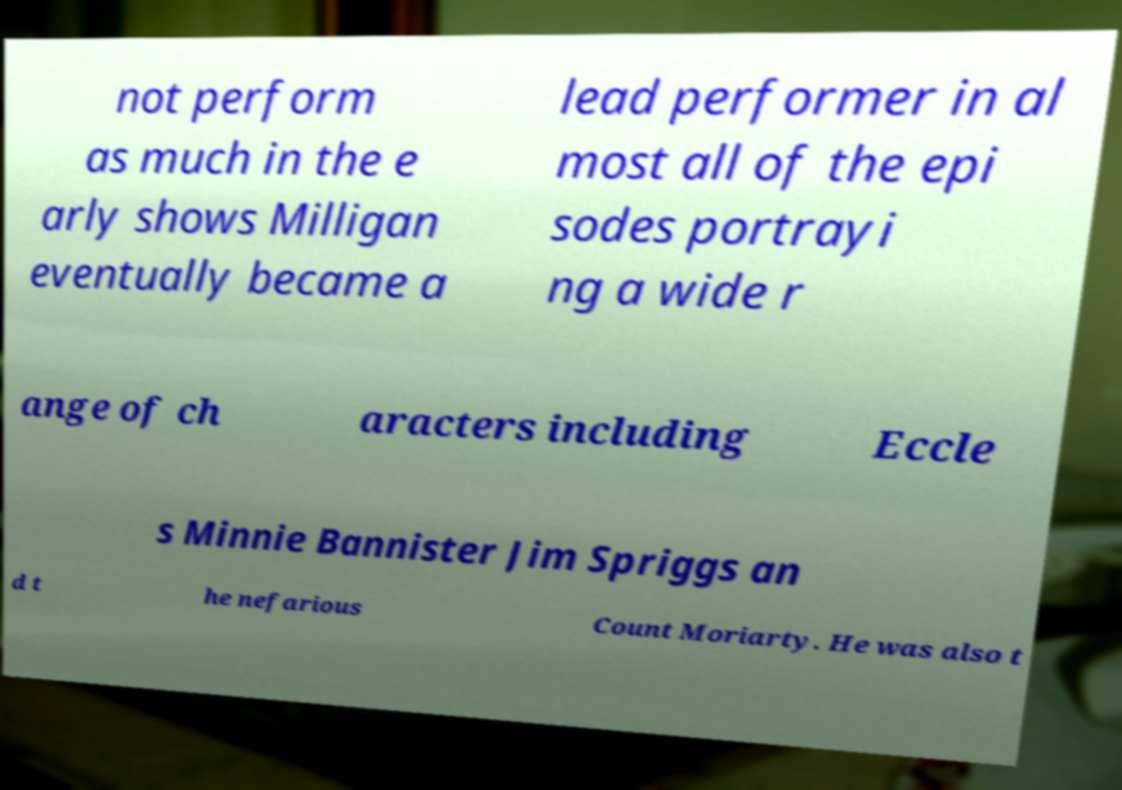Can you accurately transcribe the text from the provided image for me? not perform as much in the e arly shows Milligan eventually became a lead performer in al most all of the epi sodes portrayi ng a wide r ange of ch aracters including Eccle s Minnie Bannister Jim Spriggs an d t he nefarious Count Moriarty. He was also t 